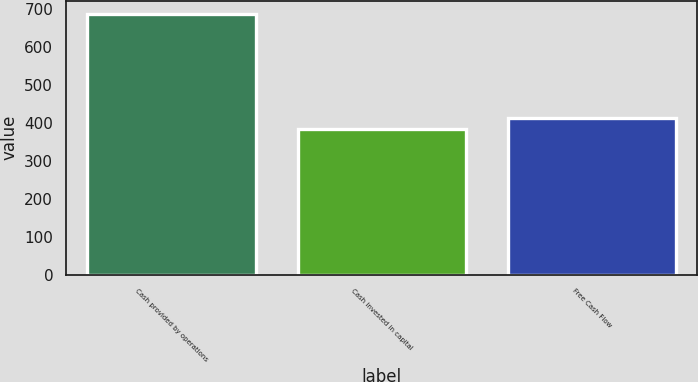Convert chart. <chart><loc_0><loc_0><loc_500><loc_500><bar_chart><fcel>Cash provided by operations<fcel>Cash invested in capital<fcel>Free Cash Flow<nl><fcel>686<fcel>382<fcel>412.4<nl></chart> 